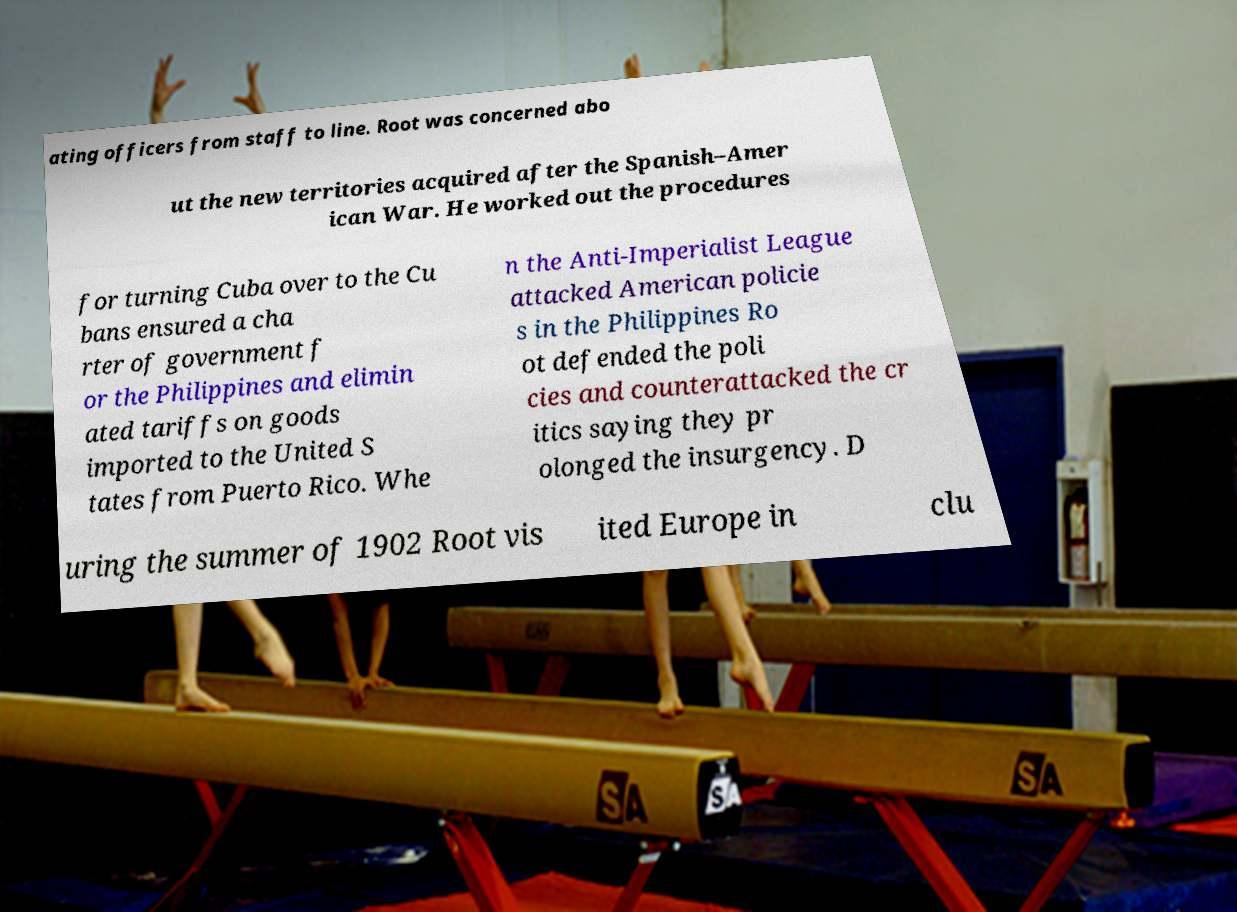Please identify and transcribe the text found in this image. ating officers from staff to line. Root was concerned abo ut the new territories acquired after the Spanish–Amer ican War. He worked out the procedures for turning Cuba over to the Cu bans ensured a cha rter of government f or the Philippines and elimin ated tariffs on goods imported to the United S tates from Puerto Rico. Whe n the Anti-Imperialist League attacked American policie s in the Philippines Ro ot defended the poli cies and counterattacked the cr itics saying they pr olonged the insurgency. D uring the summer of 1902 Root vis ited Europe in clu 